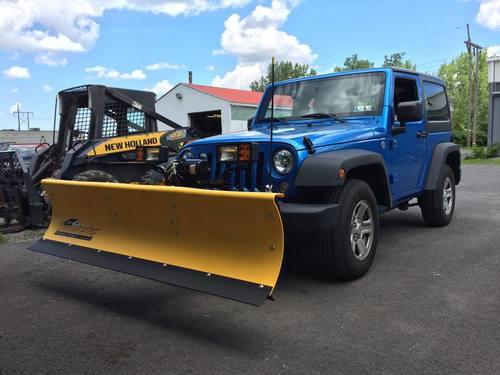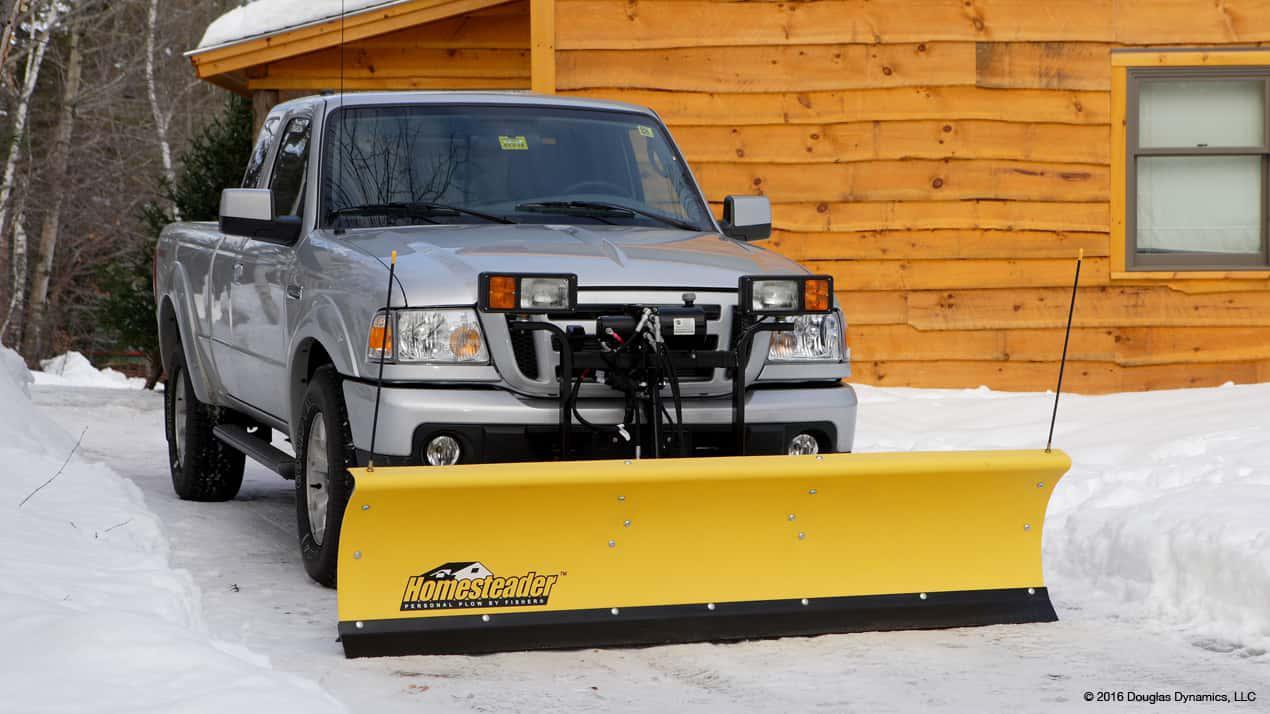The first image is the image on the left, the second image is the image on the right. For the images displayed, is the sentence "Each image shows one gray truck equipped with a bright yellow snow plow and parked on snowy ground." factually correct? Answer yes or no. No. The first image is the image on the left, the second image is the image on the right. Evaluate the accuracy of this statement regarding the images: "A blue vehicle is pushing a yellow plow in the image on the left.". Is it true? Answer yes or no. Yes. 